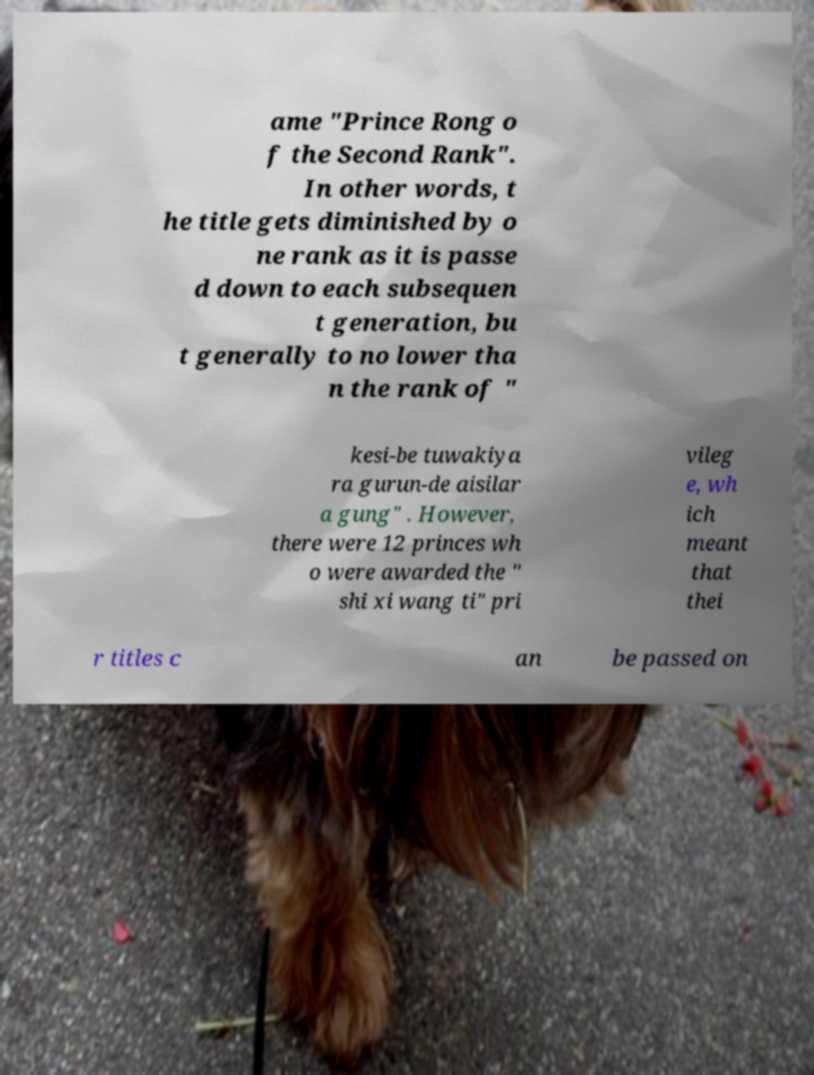Please read and relay the text visible in this image. What does it say? ame "Prince Rong o f the Second Rank". In other words, t he title gets diminished by o ne rank as it is passe d down to each subsequen t generation, bu t generally to no lower tha n the rank of " kesi-be tuwakiya ra gurun-de aisilar a gung" . However, there were 12 princes wh o were awarded the " shi xi wang ti" pri vileg e, wh ich meant that thei r titles c an be passed on 